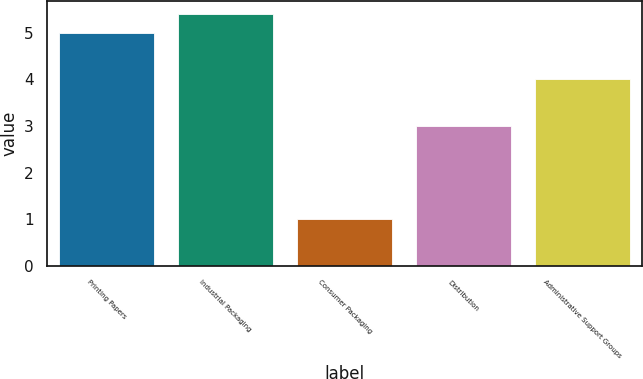Convert chart to OTSL. <chart><loc_0><loc_0><loc_500><loc_500><bar_chart><fcel>Printing Papers<fcel>Industrial Packaging<fcel>Consumer Packaging<fcel>Distribution<fcel>Administrative Support Groups<nl><fcel>5<fcel>5.4<fcel>1<fcel>3<fcel>4<nl></chart> 